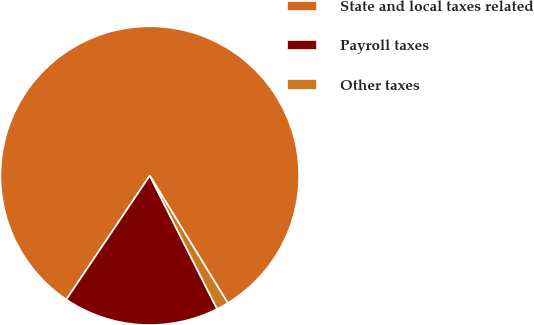Convert chart. <chart><loc_0><loc_0><loc_500><loc_500><pie_chart><fcel>State and local taxes related<fcel>Payroll taxes<fcel>Other taxes<nl><fcel>81.82%<fcel>16.88%<fcel>1.3%<nl></chart> 